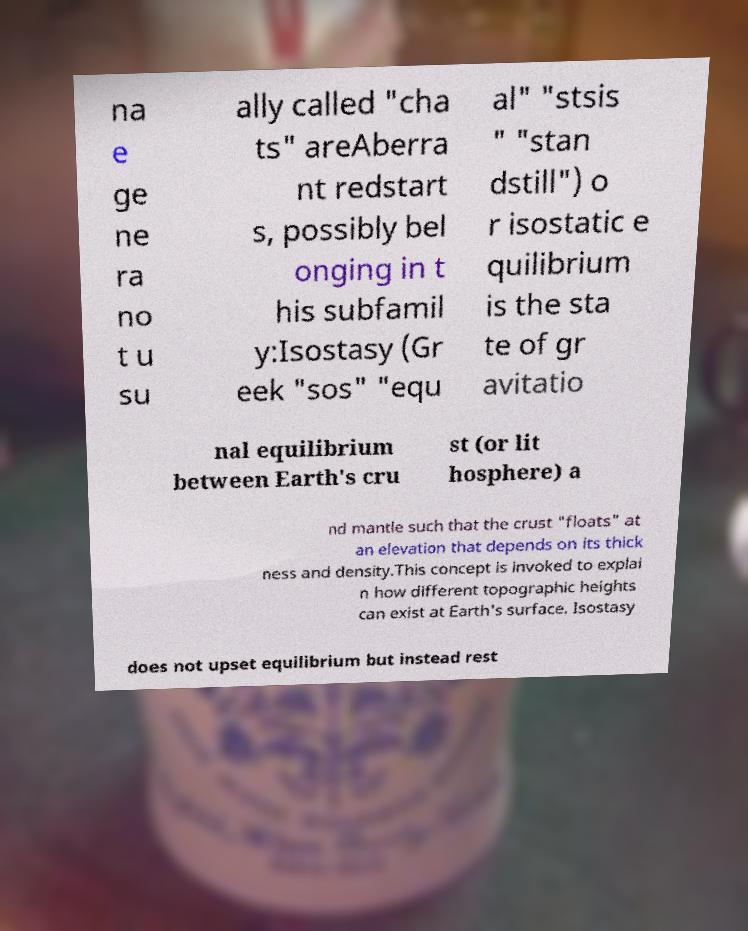Please read and relay the text visible in this image. What does it say? na e ge ne ra no t u su ally called "cha ts" areAberra nt redstart s, possibly bel onging in t his subfamil y:Isostasy (Gr eek "sos" "equ al" "stsis " "stan dstill") o r isostatic e quilibrium is the sta te of gr avitatio nal equilibrium between Earth's cru st (or lit hosphere) a nd mantle such that the crust "floats" at an elevation that depends on its thick ness and density.This concept is invoked to explai n how different topographic heights can exist at Earth's surface. Isostasy does not upset equilibrium but instead rest 